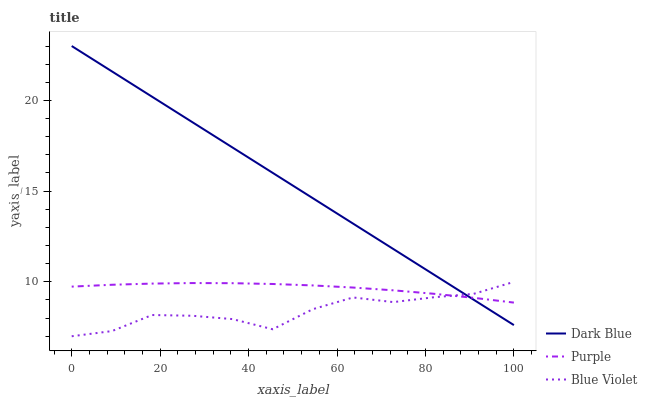Does Blue Violet have the minimum area under the curve?
Answer yes or no. Yes. Does Dark Blue have the maximum area under the curve?
Answer yes or no. Yes. Does Dark Blue have the minimum area under the curve?
Answer yes or no. No. Does Blue Violet have the maximum area under the curve?
Answer yes or no. No. Is Dark Blue the smoothest?
Answer yes or no. Yes. Is Blue Violet the roughest?
Answer yes or no. Yes. Is Blue Violet the smoothest?
Answer yes or no. No. Is Dark Blue the roughest?
Answer yes or no. No. Does Dark Blue have the lowest value?
Answer yes or no. No. Does Blue Violet have the highest value?
Answer yes or no. No. 